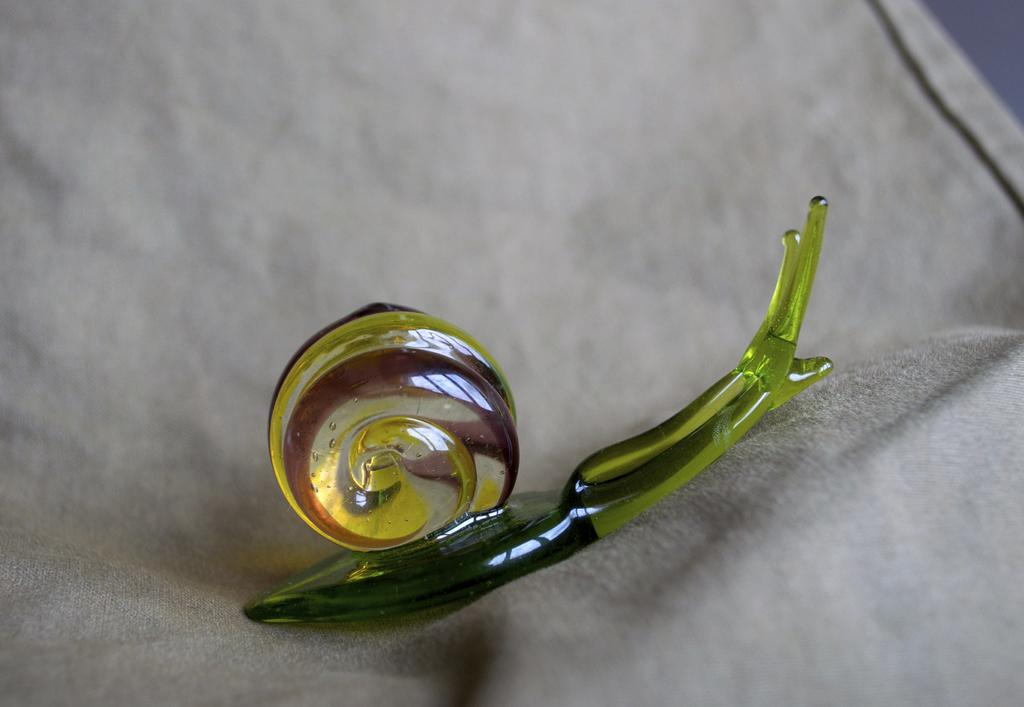What is the main subject of the image? The main subject of the image is a snail made with plastic. What material is the snail made of? The snail is made with plastic. What is the snail resting on in the image? The snail is on a cloth. What type of bread can be seen in the image? There is no bread present in the image; it features a plastic snail on a cloth. What is the texture of the ring in the image? There is no ring present in the image. 